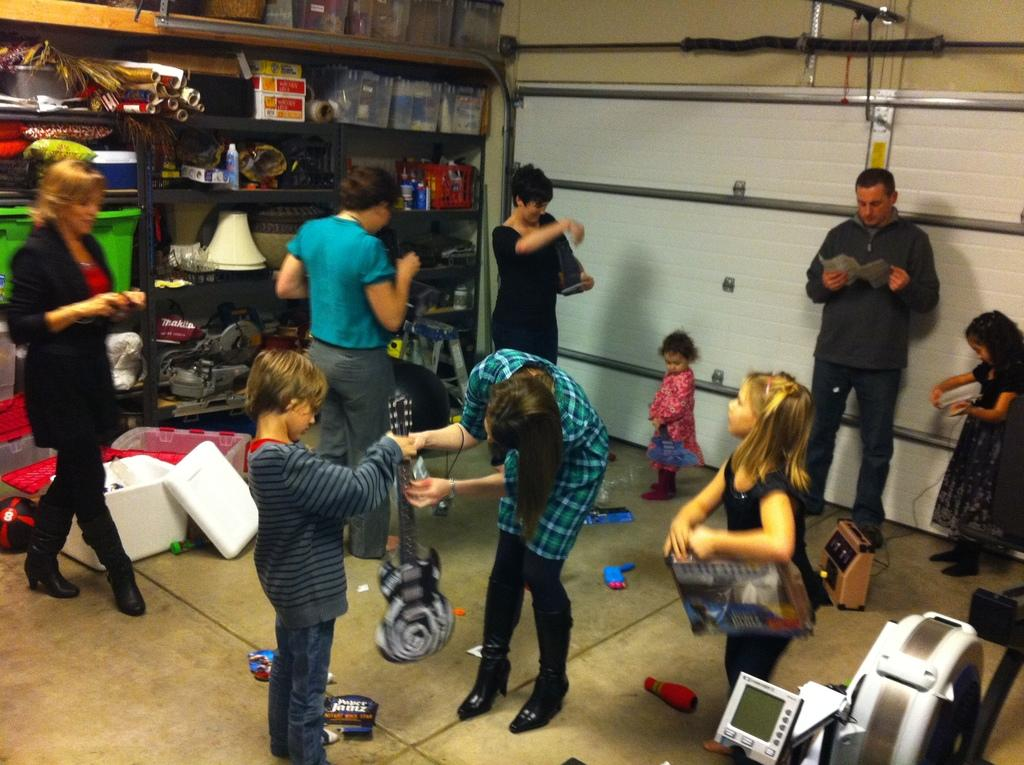Who is present in the image? There are kids and people in the image. Where was the image taken? The image was taken in a room. What can be seen on the walls of the room? There are charts in the room. What else can be found in the room? There are boxes, machines, and other objects in the room. Can you see a dock in the image? There is no dock present in the image; it is taken in a room with various objects and people. 